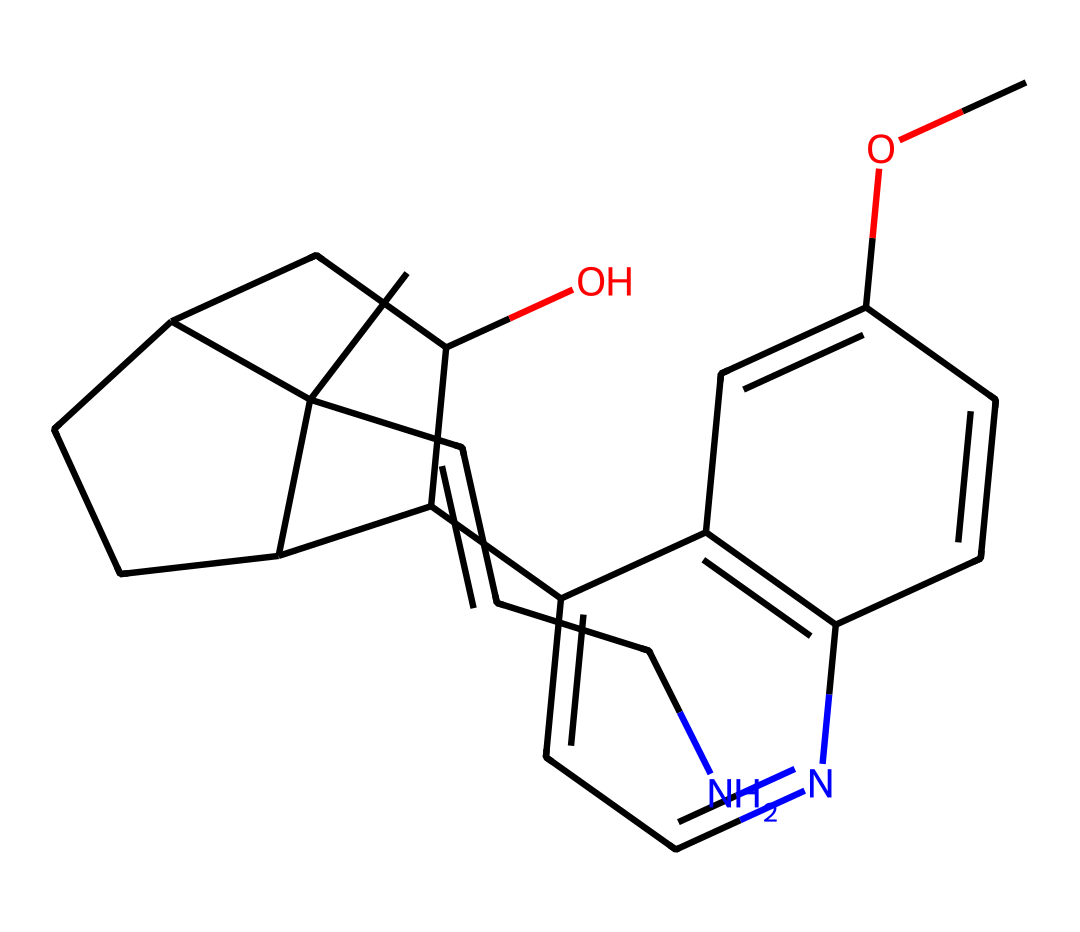How many carbon atoms are present in this molecule? By examining the SMILES representation, we can count the carbon atoms indicated by the letter "C." In this case, there are 21 carbon atoms in total.
Answer: 21 What is the primary functional group in this structure? The chemical structure contains a nitrogen atom (N), which is characteristic of alkaloids. This suggests the presence of an amine or an amide functional group.
Answer: amine Does this molecule contain a ring structure? The presence of multiple instances of "C" followed by numbers (e.g., C1, C2) in the SMILES notation indicates that there are ring structures formed by these atoms.
Answer: yes What type of alkaloid does this compound represent? Given the structure and the presence of a nitrogen atom within a bicyclic configuration, this compound can be classified as a isoquinoline alkaloid, particularly resembling quinine, used for malaria treatment.
Answer: isoquinoline How many nitrogen atoms are present in this molecule? By checking the SMILES code, we can spot that there is one nitrogen atom in the molecular arrangement, represented by "N."
Answer: 1 What characteristic does this chemical share with other antimalarial compounds? This alkaloid includes both a bicyclic structure and the presence of a quinuclidine system, which are common features among several antimalarial alkaloids, like quinine itself.
Answer: bicyclic structure What does the presence of an oxygen atom signify in this molecule? The oxygen atom (O) in the structure typically indicates potential for hydrogen bonding or a role in making the compound polar, which contributes to its solubility and biological activity, relevant for its use in treating malaria.
Answer: biological activity 